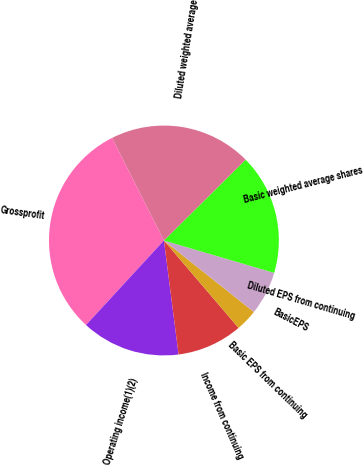<chart> <loc_0><loc_0><loc_500><loc_500><pie_chart><fcel>Grossprofit<fcel>Operating income(1)(2)<fcel>Income from continuing<fcel>Basic EPS from continuing<fcel>BasicEPS<fcel>Diluted EPS from continuing<fcel>Basic weighted average shares<fcel>Diluted weighted average<nl><fcel>30.71%<fcel>13.89%<fcel>9.21%<fcel>3.07%<fcel>6.14%<fcel>0.0%<fcel>16.96%<fcel>20.03%<nl></chart> 